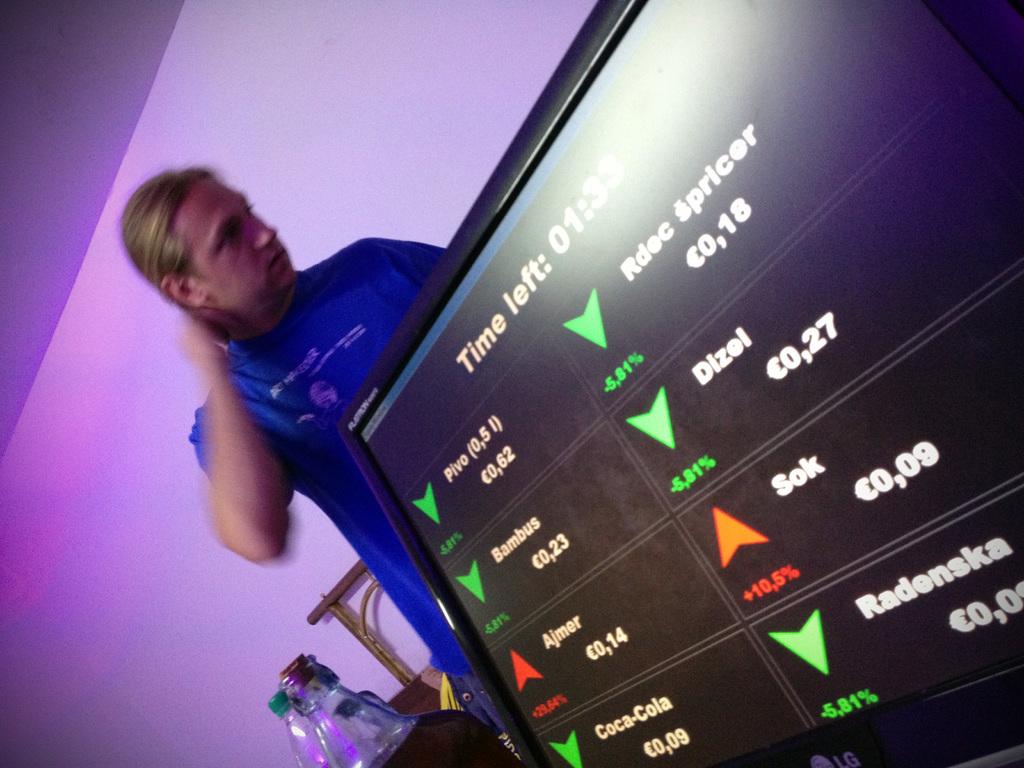Sok is down how much percent?
Offer a very short reply. 10.5. How much time is left?
Make the answer very short. 1:33. 